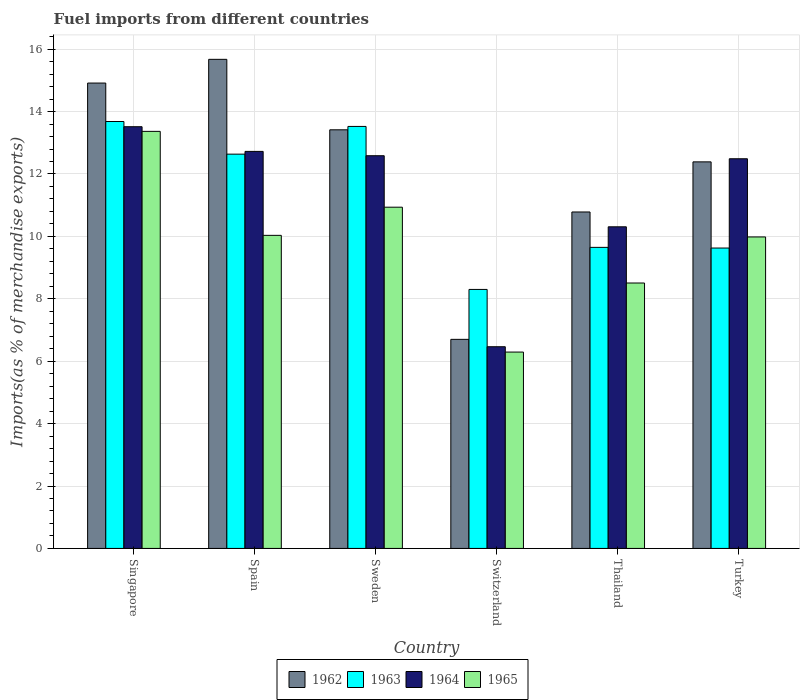How many different coloured bars are there?
Ensure brevity in your answer.  4. How many bars are there on the 1st tick from the right?
Make the answer very short. 4. In how many cases, is the number of bars for a given country not equal to the number of legend labels?
Your response must be concise. 0. What is the percentage of imports to different countries in 1964 in Spain?
Offer a terse response. 12.72. Across all countries, what is the maximum percentage of imports to different countries in 1963?
Your answer should be very brief. 13.68. Across all countries, what is the minimum percentage of imports to different countries in 1965?
Ensure brevity in your answer.  6.29. In which country was the percentage of imports to different countries in 1965 maximum?
Provide a short and direct response. Singapore. In which country was the percentage of imports to different countries in 1962 minimum?
Your response must be concise. Switzerland. What is the total percentage of imports to different countries in 1964 in the graph?
Provide a succinct answer. 68.08. What is the difference between the percentage of imports to different countries in 1964 in Singapore and that in Spain?
Your answer should be compact. 0.79. What is the difference between the percentage of imports to different countries in 1963 in Sweden and the percentage of imports to different countries in 1964 in Thailand?
Provide a succinct answer. 3.22. What is the average percentage of imports to different countries in 1962 per country?
Make the answer very short. 12.31. What is the difference between the percentage of imports to different countries of/in 1965 and percentage of imports to different countries of/in 1964 in Turkey?
Your answer should be compact. -2.51. In how many countries, is the percentage of imports to different countries in 1962 greater than 6.8 %?
Ensure brevity in your answer.  5. What is the ratio of the percentage of imports to different countries in 1963 in Singapore to that in Thailand?
Your answer should be compact. 1.42. Is the percentage of imports to different countries in 1963 in Spain less than that in Thailand?
Your response must be concise. No. Is the difference between the percentage of imports to different countries in 1965 in Singapore and Spain greater than the difference between the percentage of imports to different countries in 1964 in Singapore and Spain?
Make the answer very short. Yes. What is the difference between the highest and the second highest percentage of imports to different countries in 1962?
Ensure brevity in your answer.  -1.5. What is the difference between the highest and the lowest percentage of imports to different countries in 1964?
Give a very brief answer. 7.05. In how many countries, is the percentage of imports to different countries in 1962 greater than the average percentage of imports to different countries in 1962 taken over all countries?
Your answer should be compact. 4. Is it the case that in every country, the sum of the percentage of imports to different countries in 1965 and percentage of imports to different countries in 1963 is greater than the sum of percentage of imports to different countries in 1962 and percentage of imports to different countries in 1964?
Your answer should be very brief. No. What does the 4th bar from the left in Thailand represents?
Ensure brevity in your answer.  1965. What does the 1st bar from the right in Turkey represents?
Provide a succinct answer. 1965. Is it the case that in every country, the sum of the percentage of imports to different countries in 1962 and percentage of imports to different countries in 1965 is greater than the percentage of imports to different countries in 1963?
Your answer should be very brief. Yes. How many bars are there?
Keep it short and to the point. 24. How many countries are there in the graph?
Keep it short and to the point. 6. Does the graph contain any zero values?
Provide a short and direct response. No. Does the graph contain grids?
Provide a short and direct response. Yes. Where does the legend appear in the graph?
Your response must be concise. Bottom center. How are the legend labels stacked?
Offer a very short reply. Horizontal. What is the title of the graph?
Provide a short and direct response. Fuel imports from different countries. Does "1977" appear as one of the legend labels in the graph?
Offer a terse response. No. What is the label or title of the Y-axis?
Keep it short and to the point. Imports(as % of merchandise exports). What is the Imports(as % of merchandise exports) in 1962 in Singapore?
Provide a succinct answer. 14.91. What is the Imports(as % of merchandise exports) in 1963 in Singapore?
Your answer should be very brief. 13.68. What is the Imports(as % of merchandise exports) of 1964 in Singapore?
Your answer should be compact. 13.51. What is the Imports(as % of merchandise exports) in 1965 in Singapore?
Your answer should be very brief. 13.37. What is the Imports(as % of merchandise exports) in 1962 in Spain?
Provide a short and direct response. 15.67. What is the Imports(as % of merchandise exports) in 1963 in Spain?
Make the answer very short. 12.64. What is the Imports(as % of merchandise exports) in 1964 in Spain?
Give a very brief answer. 12.72. What is the Imports(as % of merchandise exports) of 1965 in Spain?
Ensure brevity in your answer.  10.03. What is the Imports(as % of merchandise exports) in 1962 in Sweden?
Your answer should be very brief. 13.42. What is the Imports(as % of merchandise exports) of 1963 in Sweden?
Provide a short and direct response. 13.52. What is the Imports(as % of merchandise exports) in 1964 in Sweden?
Provide a succinct answer. 12.58. What is the Imports(as % of merchandise exports) of 1965 in Sweden?
Ensure brevity in your answer.  10.93. What is the Imports(as % of merchandise exports) in 1962 in Switzerland?
Make the answer very short. 6.7. What is the Imports(as % of merchandise exports) of 1963 in Switzerland?
Ensure brevity in your answer.  8.3. What is the Imports(as % of merchandise exports) in 1964 in Switzerland?
Keep it short and to the point. 6.46. What is the Imports(as % of merchandise exports) of 1965 in Switzerland?
Your response must be concise. 6.29. What is the Imports(as % of merchandise exports) in 1962 in Thailand?
Give a very brief answer. 10.78. What is the Imports(as % of merchandise exports) in 1963 in Thailand?
Give a very brief answer. 9.65. What is the Imports(as % of merchandise exports) in 1964 in Thailand?
Your answer should be very brief. 10.31. What is the Imports(as % of merchandise exports) of 1965 in Thailand?
Give a very brief answer. 8.51. What is the Imports(as % of merchandise exports) in 1962 in Turkey?
Provide a succinct answer. 12.39. What is the Imports(as % of merchandise exports) of 1963 in Turkey?
Your answer should be compact. 9.63. What is the Imports(as % of merchandise exports) in 1964 in Turkey?
Offer a very short reply. 12.49. What is the Imports(as % of merchandise exports) of 1965 in Turkey?
Your answer should be compact. 9.98. Across all countries, what is the maximum Imports(as % of merchandise exports) in 1962?
Ensure brevity in your answer.  15.67. Across all countries, what is the maximum Imports(as % of merchandise exports) of 1963?
Keep it short and to the point. 13.68. Across all countries, what is the maximum Imports(as % of merchandise exports) in 1964?
Offer a terse response. 13.51. Across all countries, what is the maximum Imports(as % of merchandise exports) of 1965?
Provide a succinct answer. 13.37. Across all countries, what is the minimum Imports(as % of merchandise exports) in 1962?
Make the answer very short. 6.7. Across all countries, what is the minimum Imports(as % of merchandise exports) in 1963?
Your answer should be compact. 8.3. Across all countries, what is the minimum Imports(as % of merchandise exports) of 1964?
Ensure brevity in your answer.  6.46. Across all countries, what is the minimum Imports(as % of merchandise exports) of 1965?
Ensure brevity in your answer.  6.29. What is the total Imports(as % of merchandise exports) of 1962 in the graph?
Your response must be concise. 73.87. What is the total Imports(as % of merchandise exports) of 1963 in the graph?
Provide a short and direct response. 67.41. What is the total Imports(as % of merchandise exports) in 1964 in the graph?
Ensure brevity in your answer.  68.08. What is the total Imports(as % of merchandise exports) in 1965 in the graph?
Your response must be concise. 59.11. What is the difference between the Imports(as % of merchandise exports) of 1962 in Singapore and that in Spain?
Provide a succinct answer. -0.76. What is the difference between the Imports(as % of merchandise exports) of 1963 in Singapore and that in Spain?
Give a very brief answer. 1.05. What is the difference between the Imports(as % of merchandise exports) in 1964 in Singapore and that in Spain?
Offer a very short reply. 0.79. What is the difference between the Imports(as % of merchandise exports) of 1965 in Singapore and that in Spain?
Offer a very short reply. 3.33. What is the difference between the Imports(as % of merchandise exports) in 1962 in Singapore and that in Sweden?
Offer a terse response. 1.5. What is the difference between the Imports(as % of merchandise exports) in 1963 in Singapore and that in Sweden?
Offer a terse response. 0.16. What is the difference between the Imports(as % of merchandise exports) of 1964 in Singapore and that in Sweden?
Offer a terse response. 0.93. What is the difference between the Imports(as % of merchandise exports) in 1965 in Singapore and that in Sweden?
Your response must be concise. 2.43. What is the difference between the Imports(as % of merchandise exports) of 1962 in Singapore and that in Switzerland?
Offer a very short reply. 8.21. What is the difference between the Imports(as % of merchandise exports) in 1963 in Singapore and that in Switzerland?
Make the answer very short. 5.38. What is the difference between the Imports(as % of merchandise exports) of 1964 in Singapore and that in Switzerland?
Offer a terse response. 7.05. What is the difference between the Imports(as % of merchandise exports) of 1965 in Singapore and that in Switzerland?
Make the answer very short. 7.07. What is the difference between the Imports(as % of merchandise exports) in 1962 in Singapore and that in Thailand?
Provide a short and direct response. 4.13. What is the difference between the Imports(as % of merchandise exports) in 1963 in Singapore and that in Thailand?
Make the answer very short. 4.03. What is the difference between the Imports(as % of merchandise exports) of 1964 in Singapore and that in Thailand?
Make the answer very short. 3.21. What is the difference between the Imports(as % of merchandise exports) in 1965 in Singapore and that in Thailand?
Give a very brief answer. 4.86. What is the difference between the Imports(as % of merchandise exports) in 1962 in Singapore and that in Turkey?
Offer a very short reply. 2.53. What is the difference between the Imports(as % of merchandise exports) of 1963 in Singapore and that in Turkey?
Your answer should be compact. 4.05. What is the difference between the Imports(as % of merchandise exports) in 1965 in Singapore and that in Turkey?
Make the answer very short. 3.38. What is the difference between the Imports(as % of merchandise exports) in 1962 in Spain and that in Sweden?
Your response must be concise. 2.26. What is the difference between the Imports(as % of merchandise exports) of 1963 in Spain and that in Sweden?
Give a very brief answer. -0.89. What is the difference between the Imports(as % of merchandise exports) of 1964 in Spain and that in Sweden?
Your answer should be compact. 0.14. What is the difference between the Imports(as % of merchandise exports) in 1965 in Spain and that in Sweden?
Your response must be concise. -0.9. What is the difference between the Imports(as % of merchandise exports) in 1962 in Spain and that in Switzerland?
Make the answer very short. 8.97. What is the difference between the Imports(as % of merchandise exports) of 1963 in Spain and that in Switzerland?
Ensure brevity in your answer.  4.34. What is the difference between the Imports(as % of merchandise exports) in 1964 in Spain and that in Switzerland?
Make the answer very short. 6.26. What is the difference between the Imports(as % of merchandise exports) of 1965 in Spain and that in Switzerland?
Give a very brief answer. 3.74. What is the difference between the Imports(as % of merchandise exports) in 1962 in Spain and that in Thailand?
Offer a terse response. 4.89. What is the difference between the Imports(as % of merchandise exports) of 1963 in Spain and that in Thailand?
Keep it short and to the point. 2.99. What is the difference between the Imports(as % of merchandise exports) of 1964 in Spain and that in Thailand?
Your response must be concise. 2.42. What is the difference between the Imports(as % of merchandise exports) in 1965 in Spain and that in Thailand?
Provide a succinct answer. 1.53. What is the difference between the Imports(as % of merchandise exports) in 1962 in Spain and that in Turkey?
Provide a succinct answer. 3.29. What is the difference between the Imports(as % of merchandise exports) in 1963 in Spain and that in Turkey?
Give a very brief answer. 3.01. What is the difference between the Imports(as % of merchandise exports) of 1964 in Spain and that in Turkey?
Provide a succinct answer. 0.24. What is the difference between the Imports(as % of merchandise exports) in 1965 in Spain and that in Turkey?
Keep it short and to the point. 0.05. What is the difference between the Imports(as % of merchandise exports) in 1962 in Sweden and that in Switzerland?
Provide a short and direct response. 6.72. What is the difference between the Imports(as % of merchandise exports) in 1963 in Sweden and that in Switzerland?
Provide a short and direct response. 5.22. What is the difference between the Imports(as % of merchandise exports) in 1964 in Sweden and that in Switzerland?
Offer a terse response. 6.12. What is the difference between the Imports(as % of merchandise exports) of 1965 in Sweden and that in Switzerland?
Your answer should be compact. 4.64. What is the difference between the Imports(as % of merchandise exports) in 1962 in Sweden and that in Thailand?
Keep it short and to the point. 2.63. What is the difference between the Imports(as % of merchandise exports) of 1963 in Sweden and that in Thailand?
Provide a short and direct response. 3.88. What is the difference between the Imports(as % of merchandise exports) of 1964 in Sweden and that in Thailand?
Your answer should be compact. 2.28. What is the difference between the Imports(as % of merchandise exports) in 1965 in Sweden and that in Thailand?
Provide a succinct answer. 2.43. What is the difference between the Imports(as % of merchandise exports) of 1962 in Sweden and that in Turkey?
Make the answer very short. 1.03. What is the difference between the Imports(as % of merchandise exports) of 1963 in Sweden and that in Turkey?
Make the answer very short. 3.9. What is the difference between the Imports(as % of merchandise exports) in 1964 in Sweden and that in Turkey?
Provide a succinct answer. 0.1. What is the difference between the Imports(as % of merchandise exports) in 1965 in Sweden and that in Turkey?
Your answer should be very brief. 0.95. What is the difference between the Imports(as % of merchandise exports) in 1962 in Switzerland and that in Thailand?
Provide a succinct answer. -4.08. What is the difference between the Imports(as % of merchandise exports) in 1963 in Switzerland and that in Thailand?
Ensure brevity in your answer.  -1.35. What is the difference between the Imports(as % of merchandise exports) in 1964 in Switzerland and that in Thailand?
Ensure brevity in your answer.  -3.84. What is the difference between the Imports(as % of merchandise exports) in 1965 in Switzerland and that in Thailand?
Offer a very short reply. -2.21. What is the difference between the Imports(as % of merchandise exports) in 1962 in Switzerland and that in Turkey?
Provide a short and direct response. -5.69. What is the difference between the Imports(as % of merchandise exports) of 1963 in Switzerland and that in Turkey?
Give a very brief answer. -1.33. What is the difference between the Imports(as % of merchandise exports) in 1964 in Switzerland and that in Turkey?
Your response must be concise. -6.02. What is the difference between the Imports(as % of merchandise exports) in 1965 in Switzerland and that in Turkey?
Your answer should be very brief. -3.69. What is the difference between the Imports(as % of merchandise exports) in 1962 in Thailand and that in Turkey?
Your answer should be very brief. -1.61. What is the difference between the Imports(as % of merchandise exports) of 1963 in Thailand and that in Turkey?
Your answer should be very brief. 0.02. What is the difference between the Imports(as % of merchandise exports) of 1964 in Thailand and that in Turkey?
Ensure brevity in your answer.  -2.18. What is the difference between the Imports(as % of merchandise exports) of 1965 in Thailand and that in Turkey?
Provide a short and direct response. -1.48. What is the difference between the Imports(as % of merchandise exports) of 1962 in Singapore and the Imports(as % of merchandise exports) of 1963 in Spain?
Offer a very short reply. 2.28. What is the difference between the Imports(as % of merchandise exports) in 1962 in Singapore and the Imports(as % of merchandise exports) in 1964 in Spain?
Offer a terse response. 2.19. What is the difference between the Imports(as % of merchandise exports) in 1962 in Singapore and the Imports(as % of merchandise exports) in 1965 in Spain?
Offer a terse response. 4.88. What is the difference between the Imports(as % of merchandise exports) of 1963 in Singapore and the Imports(as % of merchandise exports) of 1964 in Spain?
Provide a short and direct response. 0.96. What is the difference between the Imports(as % of merchandise exports) in 1963 in Singapore and the Imports(as % of merchandise exports) in 1965 in Spain?
Your answer should be very brief. 3.65. What is the difference between the Imports(as % of merchandise exports) of 1964 in Singapore and the Imports(as % of merchandise exports) of 1965 in Spain?
Your answer should be very brief. 3.48. What is the difference between the Imports(as % of merchandise exports) of 1962 in Singapore and the Imports(as % of merchandise exports) of 1963 in Sweden?
Provide a succinct answer. 1.39. What is the difference between the Imports(as % of merchandise exports) in 1962 in Singapore and the Imports(as % of merchandise exports) in 1964 in Sweden?
Ensure brevity in your answer.  2.33. What is the difference between the Imports(as % of merchandise exports) in 1962 in Singapore and the Imports(as % of merchandise exports) in 1965 in Sweden?
Ensure brevity in your answer.  3.98. What is the difference between the Imports(as % of merchandise exports) of 1963 in Singapore and the Imports(as % of merchandise exports) of 1964 in Sweden?
Ensure brevity in your answer.  1.1. What is the difference between the Imports(as % of merchandise exports) of 1963 in Singapore and the Imports(as % of merchandise exports) of 1965 in Sweden?
Give a very brief answer. 2.75. What is the difference between the Imports(as % of merchandise exports) of 1964 in Singapore and the Imports(as % of merchandise exports) of 1965 in Sweden?
Your answer should be compact. 2.58. What is the difference between the Imports(as % of merchandise exports) of 1962 in Singapore and the Imports(as % of merchandise exports) of 1963 in Switzerland?
Make the answer very short. 6.61. What is the difference between the Imports(as % of merchandise exports) in 1962 in Singapore and the Imports(as % of merchandise exports) in 1964 in Switzerland?
Ensure brevity in your answer.  8.45. What is the difference between the Imports(as % of merchandise exports) in 1962 in Singapore and the Imports(as % of merchandise exports) in 1965 in Switzerland?
Make the answer very short. 8.62. What is the difference between the Imports(as % of merchandise exports) of 1963 in Singapore and the Imports(as % of merchandise exports) of 1964 in Switzerland?
Offer a terse response. 7.22. What is the difference between the Imports(as % of merchandise exports) in 1963 in Singapore and the Imports(as % of merchandise exports) in 1965 in Switzerland?
Your answer should be very brief. 7.39. What is the difference between the Imports(as % of merchandise exports) of 1964 in Singapore and the Imports(as % of merchandise exports) of 1965 in Switzerland?
Give a very brief answer. 7.22. What is the difference between the Imports(as % of merchandise exports) of 1962 in Singapore and the Imports(as % of merchandise exports) of 1963 in Thailand?
Keep it short and to the point. 5.27. What is the difference between the Imports(as % of merchandise exports) in 1962 in Singapore and the Imports(as % of merchandise exports) in 1964 in Thailand?
Keep it short and to the point. 4.61. What is the difference between the Imports(as % of merchandise exports) in 1962 in Singapore and the Imports(as % of merchandise exports) in 1965 in Thailand?
Your response must be concise. 6.41. What is the difference between the Imports(as % of merchandise exports) in 1963 in Singapore and the Imports(as % of merchandise exports) in 1964 in Thailand?
Your answer should be compact. 3.37. What is the difference between the Imports(as % of merchandise exports) of 1963 in Singapore and the Imports(as % of merchandise exports) of 1965 in Thailand?
Provide a short and direct response. 5.18. What is the difference between the Imports(as % of merchandise exports) of 1964 in Singapore and the Imports(as % of merchandise exports) of 1965 in Thailand?
Your answer should be compact. 5.01. What is the difference between the Imports(as % of merchandise exports) in 1962 in Singapore and the Imports(as % of merchandise exports) in 1963 in Turkey?
Keep it short and to the point. 5.29. What is the difference between the Imports(as % of merchandise exports) in 1962 in Singapore and the Imports(as % of merchandise exports) in 1964 in Turkey?
Offer a very short reply. 2.43. What is the difference between the Imports(as % of merchandise exports) in 1962 in Singapore and the Imports(as % of merchandise exports) in 1965 in Turkey?
Your answer should be very brief. 4.93. What is the difference between the Imports(as % of merchandise exports) in 1963 in Singapore and the Imports(as % of merchandise exports) in 1964 in Turkey?
Offer a very short reply. 1.19. What is the difference between the Imports(as % of merchandise exports) in 1963 in Singapore and the Imports(as % of merchandise exports) in 1965 in Turkey?
Provide a succinct answer. 3.7. What is the difference between the Imports(as % of merchandise exports) of 1964 in Singapore and the Imports(as % of merchandise exports) of 1965 in Turkey?
Provide a succinct answer. 3.53. What is the difference between the Imports(as % of merchandise exports) in 1962 in Spain and the Imports(as % of merchandise exports) in 1963 in Sweden?
Ensure brevity in your answer.  2.15. What is the difference between the Imports(as % of merchandise exports) in 1962 in Spain and the Imports(as % of merchandise exports) in 1964 in Sweden?
Ensure brevity in your answer.  3.09. What is the difference between the Imports(as % of merchandise exports) of 1962 in Spain and the Imports(as % of merchandise exports) of 1965 in Sweden?
Keep it short and to the point. 4.74. What is the difference between the Imports(as % of merchandise exports) of 1963 in Spain and the Imports(as % of merchandise exports) of 1964 in Sweden?
Provide a succinct answer. 0.05. What is the difference between the Imports(as % of merchandise exports) of 1963 in Spain and the Imports(as % of merchandise exports) of 1965 in Sweden?
Offer a terse response. 1.7. What is the difference between the Imports(as % of merchandise exports) of 1964 in Spain and the Imports(as % of merchandise exports) of 1965 in Sweden?
Make the answer very short. 1.79. What is the difference between the Imports(as % of merchandise exports) in 1962 in Spain and the Imports(as % of merchandise exports) in 1963 in Switzerland?
Give a very brief answer. 7.37. What is the difference between the Imports(as % of merchandise exports) of 1962 in Spain and the Imports(as % of merchandise exports) of 1964 in Switzerland?
Your answer should be compact. 9.21. What is the difference between the Imports(as % of merchandise exports) of 1962 in Spain and the Imports(as % of merchandise exports) of 1965 in Switzerland?
Your answer should be very brief. 9.38. What is the difference between the Imports(as % of merchandise exports) in 1963 in Spain and the Imports(as % of merchandise exports) in 1964 in Switzerland?
Keep it short and to the point. 6.17. What is the difference between the Imports(as % of merchandise exports) in 1963 in Spain and the Imports(as % of merchandise exports) in 1965 in Switzerland?
Give a very brief answer. 6.34. What is the difference between the Imports(as % of merchandise exports) in 1964 in Spain and the Imports(as % of merchandise exports) in 1965 in Switzerland?
Keep it short and to the point. 6.43. What is the difference between the Imports(as % of merchandise exports) in 1962 in Spain and the Imports(as % of merchandise exports) in 1963 in Thailand?
Your response must be concise. 6.03. What is the difference between the Imports(as % of merchandise exports) of 1962 in Spain and the Imports(as % of merchandise exports) of 1964 in Thailand?
Your answer should be compact. 5.37. What is the difference between the Imports(as % of merchandise exports) of 1962 in Spain and the Imports(as % of merchandise exports) of 1965 in Thailand?
Keep it short and to the point. 7.17. What is the difference between the Imports(as % of merchandise exports) in 1963 in Spain and the Imports(as % of merchandise exports) in 1964 in Thailand?
Offer a very short reply. 2.33. What is the difference between the Imports(as % of merchandise exports) in 1963 in Spain and the Imports(as % of merchandise exports) in 1965 in Thailand?
Your answer should be very brief. 4.13. What is the difference between the Imports(as % of merchandise exports) in 1964 in Spain and the Imports(as % of merchandise exports) in 1965 in Thailand?
Make the answer very short. 4.22. What is the difference between the Imports(as % of merchandise exports) in 1962 in Spain and the Imports(as % of merchandise exports) in 1963 in Turkey?
Offer a terse response. 6.05. What is the difference between the Imports(as % of merchandise exports) of 1962 in Spain and the Imports(as % of merchandise exports) of 1964 in Turkey?
Keep it short and to the point. 3.19. What is the difference between the Imports(as % of merchandise exports) of 1962 in Spain and the Imports(as % of merchandise exports) of 1965 in Turkey?
Provide a short and direct response. 5.69. What is the difference between the Imports(as % of merchandise exports) of 1963 in Spain and the Imports(as % of merchandise exports) of 1964 in Turkey?
Make the answer very short. 0.15. What is the difference between the Imports(as % of merchandise exports) in 1963 in Spain and the Imports(as % of merchandise exports) in 1965 in Turkey?
Your response must be concise. 2.65. What is the difference between the Imports(as % of merchandise exports) of 1964 in Spain and the Imports(as % of merchandise exports) of 1965 in Turkey?
Your answer should be compact. 2.74. What is the difference between the Imports(as % of merchandise exports) in 1962 in Sweden and the Imports(as % of merchandise exports) in 1963 in Switzerland?
Ensure brevity in your answer.  5.12. What is the difference between the Imports(as % of merchandise exports) of 1962 in Sweden and the Imports(as % of merchandise exports) of 1964 in Switzerland?
Keep it short and to the point. 6.95. What is the difference between the Imports(as % of merchandise exports) in 1962 in Sweden and the Imports(as % of merchandise exports) in 1965 in Switzerland?
Offer a very short reply. 7.12. What is the difference between the Imports(as % of merchandise exports) in 1963 in Sweden and the Imports(as % of merchandise exports) in 1964 in Switzerland?
Offer a terse response. 7.06. What is the difference between the Imports(as % of merchandise exports) of 1963 in Sweden and the Imports(as % of merchandise exports) of 1965 in Switzerland?
Provide a succinct answer. 7.23. What is the difference between the Imports(as % of merchandise exports) in 1964 in Sweden and the Imports(as % of merchandise exports) in 1965 in Switzerland?
Give a very brief answer. 6.29. What is the difference between the Imports(as % of merchandise exports) of 1962 in Sweden and the Imports(as % of merchandise exports) of 1963 in Thailand?
Your answer should be very brief. 3.77. What is the difference between the Imports(as % of merchandise exports) in 1962 in Sweden and the Imports(as % of merchandise exports) in 1964 in Thailand?
Your answer should be very brief. 3.11. What is the difference between the Imports(as % of merchandise exports) of 1962 in Sweden and the Imports(as % of merchandise exports) of 1965 in Thailand?
Give a very brief answer. 4.91. What is the difference between the Imports(as % of merchandise exports) in 1963 in Sweden and the Imports(as % of merchandise exports) in 1964 in Thailand?
Your response must be concise. 3.22. What is the difference between the Imports(as % of merchandise exports) in 1963 in Sweden and the Imports(as % of merchandise exports) in 1965 in Thailand?
Your answer should be very brief. 5.02. What is the difference between the Imports(as % of merchandise exports) of 1964 in Sweden and the Imports(as % of merchandise exports) of 1965 in Thailand?
Make the answer very short. 4.08. What is the difference between the Imports(as % of merchandise exports) of 1962 in Sweden and the Imports(as % of merchandise exports) of 1963 in Turkey?
Your response must be concise. 3.79. What is the difference between the Imports(as % of merchandise exports) of 1962 in Sweden and the Imports(as % of merchandise exports) of 1964 in Turkey?
Your answer should be compact. 0.93. What is the difference between the Imports(as % of merchandise exports) of 1962 in Sweden and the Imports(as % of merchandise exports) of 1965 in Turkey?
Give a very brief answer. 3.43. What is the difference between the Imports(as % of merchandise exports) in 1963 in Sweden and the Imports(as % of merchandise exports) in 1964 in Turkey?
Your answer should be compact. 1.04. What is the difference between the Imports(as % of merchandise exports) in 1963 in Sweden and the Imports(as % of merchandise exports) in 1965 in Turkey?
Offer a terse response. 3.54. What is the difference between the Imports(as % of merchandise exports) in 1964 in Sweden and the Imports(as % of merchandise exports) in 1965 in Turkey?
Keep it short and to the point. 2.6. What is the difference between the Imports(as % of merchandise exports) of 1962 in Switzerland and the Imports(as % of merchandise exports) of 1963 in Thailand?
Provide a short and direct response. -2.95. What is the difference between the Imports(as % of merchandise exports) of 1962 in Switzerland and the Imports(as % of merchandise exports) of 1964 in Thailand?
Offer a very short reply. -3.61. What is the difference between the Imports(as % of merchandise exports) of 1962 in Switzerland and the Imports(as % of merchandise exports) of 1965 in Thailand?
Provide a succinct answer. -1.81. What is the difference between the Imports(as % of merchandise exports) in 1963 in Switzerland and the Imports(as % of merchandise exports) in 1964 in Thailand?
Give a very brief answer. -2.01. What is the difference between the Imports(as % of merchandise exports) of 1963 in Switzerland and the Imports(as % of merchandise exports) of 1965 in Thailand?
Ensure brevity in your answer.  -0.21. What is the difference between the Imports(as % of merchandise exports) of 1964 in Switzerland and the Imports(as % of merchandise exports) of 1965 in Thailand?
Your response must be concise. -2.04. What is the difference between the Imports(as % of merchandise exports) in 1962 in Switzerland and the Imports(as % of merchandise exports) in 1963 in Turkey?
Your response must be concise. -2.93. What is the difference between the Imports(as % of merchandise exports) of 1962 in Switzerland and the Imports(as % of merchandise exports) of 1964 in Turkey?
Provide a short and direct response. -5.79. What is the difference between the Imports(as % of merchandise exports) in 1962 in Switzerland and the Imports(as % of merchandise exports) in 1965 in Turkey?
Give a very brief answer. -3.28. What is the difference between the Imports(as % of merchandise exports) in 1963 in Switzerland and the Imports(as % of merchandise exports) in 1964 in Turkey?
Offer a very short reply. -4.19. What is the difference between the Imports(as % of merchandise exports) in 1963 in Switzerland and the Imports(as % of merchandise exports) in 1965 in Turkey?
Your response must be concise. -1.68. What is the difference between the Imports(as % of merchandise exports) in 1964 in Switzerland and the Imports(as % of merchandise exports) in 1965 in Turkey?
Your answer should be compact. -3.52. What is the difference between the Imports(as % of merchandise exports) in 1962 in Thailand and the Imports(as % of merchandise exports) in 1963 in Turkey?
Provide a short and direct response. 1.16. What is the difference between the Imports(as % of merchandise exports) in 1962 in Thailand and the Imports(as % of merchandise exports) in 1964 in Turkey?
Keep it short and to the point. -1.71. What is the difference between the Imports(as % of merchandise exports) of 1963 in Thailand and the Imports(as % of merchandise exports) of 1964 in Turkey?
Offer a very short reply. -2.84. What is the difference between the Imports(as % of merchandise exports) of 1963 in Thailand and the Imports(as % of merchandise exports) of 1965 in Turkey?
Give a very brief answer. -0.33. What is the difference between the Imports(as % of merchandise exports) in 1964 in Thailand and the Imports(as % of merchandise exports) in 1965 in Turkey?
Your response must be concise. 0.32. What is the average Imports(as % of merchandise exports) in 1962 per country?
Your answer should be very brief. 12.31. What is the average Imports(as % of merchandise exports) of 1963 per country?
Your response must be concise. 11.24. What is the average Imports(as % of merchandise exports) in 1964 per country?
Offer a very short reply. 11.35. What is the average Imports(as % of merchandise exports) of 1965 per country?
Offer a terse response. 9.85. What is the difference between the Imports(as % of merchandise exports) of 1962 and Imports(as % of merchandise exports) of 1963 in Singapore?
Keep it short and to the point. 1.23. What is the difference between the Imports(as % of merchandise exports) of 1962 and Imports(as % of merchandise exports) of 1964 in Singapore?
Your answer should be very brief. 1.4. What is the difference between the Imports(as % of merchandise exports) of 1962 and Imports(as % of merchandise exports) of 1965 in Singapore?
Provide a short and direct response. 1.55. What is the difference between the Imports(as % of merchandise exports) in 1963 and Imports(as % of merchandise exports) in 1964 in Singapore?
Your answer should be very brief. 0.17. What is the difference between the Imports(as % of merchandise exports) of 1963 and Imports(as % of merchandise exports) of 1965 in Singapore?
Your answer should be very brief. 0.32. What is the difference between the Imports(as % of merchandise exports) of 1964 and Imports(as % of merchandise exports) of 1965 in Singapore?
Offer a terse response. 0.15. What is the difference between the Imports(as % of merchandise exports) of 1962 and Imports(as % of merchandise exports) of 1963 in Spain?
Give a very brief answer. 3.04. What is the difference between the Imports(as % of merchandise exports) of 1962 and Imports(as % of merchandise exports) of 1964 in Spain?
Offer a very short reply. 2.95. What is the difference between the Imports(as % of merchandise exports) of 1962 and Imports(as % of merchandise exports) of 1965 in Spain?
Provide a short and direct response. 5.64. What is the difference between the Imports(as % of merchandise exports) in 1963 and Imports(as % of merchandise exports) in 1964 in Spain?
Offer a very short reply. -0.09. What is the difference between the Imports(as % of merchandise exports) of 1963 and Imports(as % of merchandise exports) of 1965 in Spain?
Provide a succinct answer. 2.6. What is the difference between the Imports(as % of merchandise exports) of 1964 and Imports(as % of merchandise exports) of 1965 in Spain?
Offer a very short reply. 2.69. What is the difference between the Imports(as % of merchandise exports) of 1962 and Imports(as % of merchandise exports) of 1963 in Sweden?
Your response must be concise. -0.11. What is the difference between the Imports(as % of merchandise exports) of 1962 and Imports(as % of merchandise exports) of 1964 in Sweden?
Keep it short and to the point. 0.83. What is the difference between the Imports(as % of merchandise exports) in 1962 and Imports(as % of merchandise exports) in 1965 in Sweden?
Make the answer very short. 2.48. What is the difference between the Imports(as % of merchandise exports) of 1963 and Imports(as % of merchandise exports) of 1964 in Sweden?
Your answer should be compact. 0.94. What is the difference between the Imports(as % of merchandise exports) in 1963 and Imports(as % of merchandise exports) in 1965 in Sweden?
Give a very brief answer. 2.59. What is the difference between the Imports(as % of merchandise exports) of 1964 and Imports(as % of merchandise exports) of 1965 in Sweden?
Your answer should be compact. 1.65. What is the difference between the Imports(as % of merchandise exports) in 1962 and Imports(as % of merchandise exports) in 1963 in Switzerland?
Ensure brevity in your answer.  -1.6. What is the difference between the Imports(as % of merchandise exports) in 1962 and Imports(as % of merchandise exports) in 1964 in Switzerland?
Offer a very short reply. 0.24. What is the difference between the Imports(as % of merchandise exports) in 1962 and Imports(as % of merchandise exports) in 1965 in Switzerland?
Give a very brief answer. 0.41. What is the difference between the Imports(as % of merchandise exports) in 1963 and Imports(as % of merchandise exports) in 1964 in Switzerland?
Give a very brief answer. 1.84. What is the difference between the Imports(as % of merchandise exports) in 1963 and Imports(as % of merchandise exports) in 1965 in Switzerland?
Your response must be concise. 2.01. What is the difference between the Imports(as % of merchandise exports) of 1964 and Imports(as % of merchandise exports) of 1965 in Switzerland?
Your answer should be compact. 0.17. What is the difference between the Imports(as % of merchandise exports) of 1962 and Imports(as % of merchandise exports) of 1963 in Thailand?
Provide a succinct answer. 1.13. What is the difference between the Imports(as % of merchandise exports) in 1962 and Imports(as % of merchandise exports) in 1964 in Thailand?
Offer a terse response. 0.48. What is the difference between the Imports(as % of merchandise exports) in 1962 and Imports(as % of merchandise exports) in 1965 in Thailand?
Offer a very short reply. 2.28. What is the difference between the Imports(as % of merchandise exports) of 1963 and Imports(as % of merchandise exports) of 1964 in Thailand?
Keep it short and to the point. -0.66. What is the difference between the Imports(as % of merchandise exports) of 1963 and Imports(as % of merchandise exports) of 1965 in Thailand?
Keep it short and to the point. 1.14. What is the difference between the Imports(as % of merchandise exports) of 1964 and Imports(as % of merchandise exports) of 1965 in Thailand?
Provide a succinct answer. 1.8. What is the difference between the Imports(as % of merchandise exports) in 1962 and Imports(as % of merchandise exports) in 1963 in Turkey?
Provide a short and direct response. 2.76. What is the difference between the Imports(as % of merchandise exports) in 1962 and Imports(as % of merchandise exports) in 1964 in Turkey?
Provide a succinct answer. -0.1. What is the difference between the Imports(as % of merchandise exports) of 1962 and Imports(as % of merchandise exports) of 1965 in Turkey?
Offer a terse response. 2.41. What is the difference between the Imports(as % of merchandise exports) in 1963 and Imports(as % of merchandise exports) in 1964 in Turkey?
Offer a terse response. -2.86. What is the difference between the Imports(as % of merchandise exports) in 1963 and Imports(as % of merchandise exports) in 1965 in Turkey?
Your answer should be compact. -0.36. What is the difference between the Imports(as % of merchandise exports) in 1964 and Imports(as % of merchandise exports) in 1965 in Turkey?
Ensure brevity in your answer.  2.51. What is the ratio of the Imports(as % of merchandise exports) in 1962 in Singapore to that in Spain?
Provide a short and direct response. 0.95. What is the ratio of the Imports(as % of merchandise exports) in 1963 in Singapore to that in Spain?
Ensure brevity in your answer.  1.08. What is the ratio of the Imports(as % of merchandise exports) of 1964 in Singapore to that in Spain?
Provide a succinct answer. 1.06. What is the ratio of the Imports(as % of merchandise exports) of 1965 in Singapore to that in Spain?
Your answer should be compact. 1.33. What is the ratio of the Imports(as % of merchandise exports) of 1962 in Singapore to that in Sweden?
Your answer should be compact. 1.11. What is the ratio of the Imports(as % of merchandise exports) of 1963 in Singapore to that in Sweden?
Your answer should be compact. 1.01. What is the ratio of the Imports(as % of merchandise exports) of 1964 in Singapore to that in Sweden?
Provide a succinct answer. 1.07. What is the ratio of the Imports(as % of merchandise exports) in 1965 in Singapore to that in Sweden?
Give a very brief answer. 1.22. What is the ratio of the Imports(as % of merchandise exports) in 1962 in Singapore to that in Switzerland?
Ensure brevity in your answer.  2.23. What is the ratio of the Imports(as % of merchandise exports) of 1963 in Singapore to that in Switzerland?
Provide a succinct answer. 1.65. What is the ratio of the Imports(as % of merchandise exports) in 1964 in Singapore to that in Switzerland?
Your response must be concise. 2.09. What is the ratio of the Imports(as % of merchandise exports) in 1965 in Singapore to that in Switzerland?
Ensure brevity in your answer.  2.12. What is the ratio of the Imports(as % of merchandise exports) in 1962 in Singapore to that in Thailand?
Give a very brief answer. 1.38. What is the ratio of the Imports(as % of merchandise exports) in 1963 in Singapore to that in Thailand?
Offer a very short reply. 1.42. What is the ratio of the Imports(as % of merchandise exports) of 1964 in Singapore to that in Thailand?
Offer a terse response. 1.31. What is the ratio of the Imports(as % of merchandise exports) in 1965 in Singapore to that in Thailand?
Offer a terse response. 1.57. What is the ratio of the Imports(as % of merchandise exports) of 1962 in Singapore to that in Turkey?
Your answer should be compact. 1.2. What is the ratio of the Imports(as % of merchandise exports) of 1963 in Singapore to that in Turkey?
Your answer should be compact. 1.42. What is the ratio of the Imports(as % of merchandise exports) of 1964 in Singapore to that in Turkey?
Offer a very short reply. 1.08. What is the ratio of the Imports(as % of merchandise exports) in 1965 in Singapore to that in Turkey?
Your response must be concise. 1.34. What is the ratio of the Imports(as % of merchandise exports) in 1962 in Spain to that in Sweden?
Your response must be concise. 1.17. What is the ratio of the Imports(as % of merchandise exports) in 1963 in Spain to that in Sweden?
Your answer should be very brief. 0.93. What is the ratio of the Imports(as % of merchandise exports) in 1965 in Spain to that in Sweden?
Give a very brief answer. 0.92. What is the ratio of the Imports(as % of merchandise exports) in 1962 in Spain to that in Switzerland?
Keep it short and to the point. 2.34. What is the ratio of the Imports(as % of merchandise exports) in 1963 in Spain to that in Switzerland?
Your response must be concise. 1.52. What is the ratio of the Imports(as % of merchandise exports) in 1964 in Spain to that in Switzerland?
Your answer should be compact. 1.97. What is the ratio of the Imports(as % of merchandise exports) of 1965 in Spain to that in Switzerland?
Keep it short and to the point. 1.59. What is the ratio of the Imports(as % of merchandise exports) of 1962 in Spain to that in Thailand?
Give a very brief answer. 1.45. What is the ratio of the Imports(as % of merchandise exports) in 1963 in Spain to that in Thailand?
Your response must be concise. 1.31. What is the ratio of the Imports(as % of merchandise exports) of 1964 in Spain to that in Thailand?
Offer a very short reply. 1.23. What is the ratio of the Imports(as % of merchandise exports) in 1965 in Spain to that in Thailand?
Give a very brief answer. 1.18. What is the ratio of the Imports(as % of merchandise exports) of 1962 in Spain to that in Turkey?
Provide a succinct answer. 1.27. What is the ratio of the Imports(as % of merchandise exports) in 1963 in Spain to that in Turkey?
Your response must be concise. 1.31. What is the ratio of the Imports(as % of merchandise exports) in 1964 in Spain to that in Turkey?
Your answer should be very brief. 1.02. What is the ratio of the Imports(as % of merchandise exports) of 1965 in Spain to that in Turkey?
Give a very brief answer. 1.01. What is the ratio of the Imports(as % of merchandise exports) of 1962 in Sweden to that in Switzerland?
Offer a very short reply. 2. What is the ratio of the Imports(as % of merchandise exports) in 1963 in Sweden to that in Switzerland?
Your response must be concise. 1.63. What is the ratio of the Imports(as % of merchandise exports) in 1964 in Sweden to that in Switzerland?
Ensure brevity in your answer.  1.95. What is the ratio of the Imports(as % of merchandise exports) in 1965 in Sweden to that in Switzerland?
Your answer should be compact. 1.74. What is the ratio of the Imports(as % of merchandise exports) of 1962 in Sweden to that in Thailand?
Ensure brevity in your answer.  1.24. What is the ratio of the Imports(as % of merchandise exports) of 1963 in Sweden to that in Thailand?
Ensure brevity in your answer.  1.4. What is the ratio of the Imports(as % of merchandise exports) in 1964 in Sweden to that in Thailand?
Provide a succinct answer. 1.22. What is the ratio of the Imports(as % of merchandise exports) of 1965 in Sweden to that in Thailand?
Your response must be concise. 1.29. What is the ratio of the Imports(as % of merchandise exports) in 1962 in Sweden to that in Turkey?
Ensure brevity in your answer.  1.08. What is the ratio of the Imports(as % of merchandise exports) in 1963 in Sweden to that in Turkey?
Ensure brevity in your answer.  1.4. What is the ratio of the Imports(as % of merchandise exports) in 1964 in Sweden to that in Turkey?
Your response must be concise. 1.01. What is the ratio of the Imports(as % of merchandise exports) of 1965 in Sweden to that in Turkey?
Make the answer very short. 1.1. What is the ratio of the Imports(as % of merchandise exports) of 1962 in Switzerland to that in Thailand?
Make the answer very short. 0.62. What is the ratio of the Imports(as % of merchandise exports) in 1963 in Switzerland to that in Thailand?
Ensure brevity in your answer.  0.86. What is the ratio of the Imports(as % of merchandise exports) in 1964 in Switzerland to that in Thailand?
Give a very brief answer. 0.63. What is the ratio of the Imports(as % of merchandise exports) in 1965 in Switzerland to that in Thailand?
Offer a very short reply. 0.74. What is the ratio of the Imports(as % of merchandise exports) in 1962 in Switzerland to that in Turkey?
Ensure brevity in your answer.  0.54. What is the ratio of the Imports(as % of merchandise exports) of 1963 in Switzerland to that in Turkey?
Provide a short and direct response. 0.86. What is the ratio of the Imports(as % of merchandise exports) in 1964 in Switzerland to that in Turkey?
Make the answer very short. 0.52. What is the ratio of the Imports(as % of merchandise exports) in 1965 in Switzerland to that in Turkey?
Make the answer very short. 0.63. What is the ratio of the Imports(as % of merchandise exports) of 1962 in Thailand to that in Turkey?
Provide a short and direct response. 0.87. What is the ratio of the Imports(as % of merchandise exports) of 1963 in Thailand to that in Turkey?
Keep it short and to the point. 1. What is the ratio of the Imports(as % of merchandise exports) of 1964 in Thailand to that in Turkey?
Provide a succinct answer. 0.83. What is the ratio of the Imports(as % of merchandise exports) of 1965 in Thailand to that in Turkey?
Your answer should be very brief. 0.85. What is the difference between the highest and the second highest Imports(as % of merchandise exports) of 1962?
Your response must be concise. 0.76. What is the difference between the highest and the second highest Imports(as % of merchandise exports) of 1963?
Make the answer very short. 0.16. What is the difference between the highest and the second highest Imports(as % of merchandise exports) in 1964?
Give a very brief answer. 0.79. What is the difference between the highest and the second highest Imports(as % of merchandise exports) of 1965?
Ensure brevity in your answer.  2.43. What is the difference between the highest and the lowest Imports(as % of merchandise exports) in 1962?
Ensure brevity in your answer.  8.97. What is the difference between the highest and the lowest Imports(as % of merchandise exports) in 1963?
Make the answer very short. 5.38. What is the difference between the highest and the lowest Imports(as % of merchandise exports) in 1964?
Give a very brief answer. 7.05. What is the difference between the highest and the lowest Imports(as % of merchandise exports) in 1965?
Your answer should be compact. 7.07. 